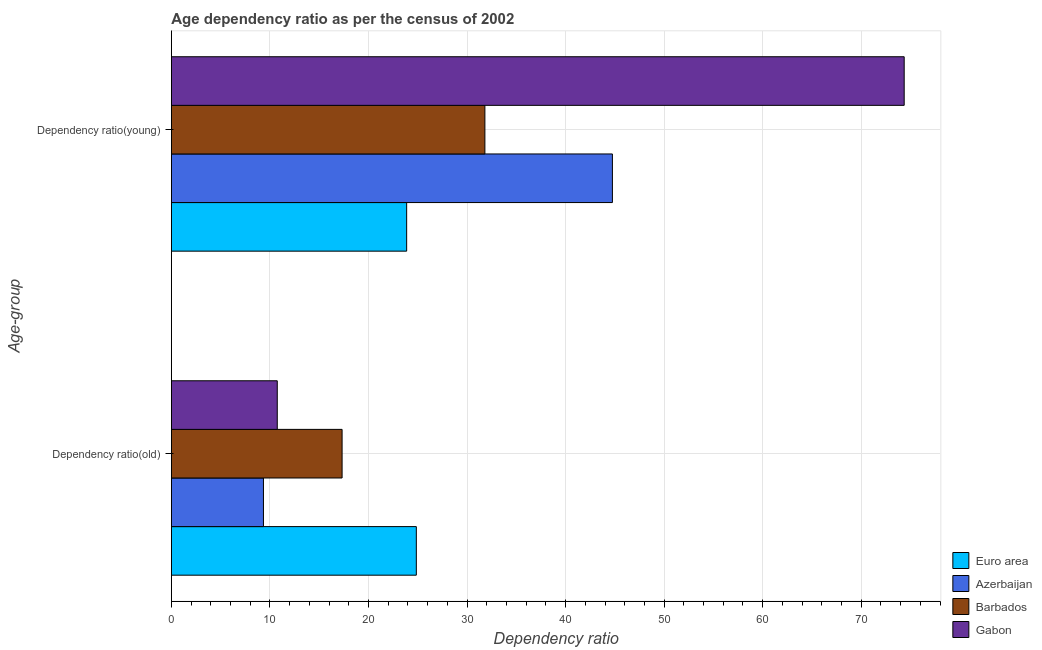How many groups of bars are there?
Offer a terse response. 2. How many bars are there on the 2nd tick from the bottom?
Your answer should be very brief. 4. What is the label of the 1st group of bars from the top?
Your answer should be compact. Dependency ratio(young). What is the age dependency ratio(old) in Barbados?
Your answer should be compact. 17.32. Across all countries, what is the maximum age dependency ratio(old)?
Keep it short and to the point. 24.85. Across all countries, what is the minimum age dependency ratio(young)?
Offer a terse response. 23.87. In which country was the age dependency ratio(old) minimum?
Make the answer very short. Azerbaijan. What is the total age dependency ratio(young) in the graph?
Your answer should be compact. 174.8. What is the difference between the age dependency ratio(young) in Azerbaijan and that in Barbados?
Make the answer very short. 12.94. What is the difference between the age dependency ratio(old) in Gabon and the age dependency ratio(young) in Barbados?
Give a very brief answer. -21.07. What is the average age dependency ratio(old) per country?
Offer a terse response. 15.57. What is the difference between the age dependency ratio(old) and age dependency ratio(young) in Azerbaijan?
Keep it short and to the point. -35.41. What is the ratio of the age dependency ratio(old) in Azerbaijan to that in Barbados?
Offer a terse response. 0.54. Is the age dependency ratio(old) in Gabon less than that in Euro area?
Keep it short and to the point. Yes. In how many countries, is the age dependency ratio(young) greater than the average age dependency ratio(young) taken over all countries?
Ensure brevity in your answer.  2. What does the 4th bar from the top in Dependency ratio(young) represents?
Make the answer very short. Euro area. What does the 2nd bar from the bottom in Dependency ratio(old) represents?
Your answer should be very brief. Azerbaijan. How many countries are there in the graph?
Your answer should be very brief. 4. Are the values on the major ticks of X-axis written in scientific E-notation?
Make the answer very short. No. Does the graph contain grids?
Your answer should be very brief. Yes. How many legend labels are there?
Offer a terse response. 4. How are the legend labels stacked?
Provide a short and direct response. Vertical. What is the title of the graph?
Make the answer very short. Age dependency ratio as per the census of 2002. What is the label or title of the X-axis?
Provide a short and direct response. Dependency ratio. What is the label or title of the Y-axis?
Your answer should be very brief. Age-group. What is the Dependency ratio in Euro area in Dependency ratio(old)?
Make the answer very short. 24.85. What is the Dependency ratio of Azerbaijan in Dependency ratio(old)?
Keep it short and to the point. 9.34. What is the Dependency ratio of Barbados in Dependency ratio(old)?
Give a very brief answer. 17.32. What is the Dependency ratio of Gabon in Dependency ratio(old)?
Make the answer very short. 10.74. What is the Dependency ratio of Euro area in Dependency ratio(young)?
Ensure brevity in your answer.  23.87. What is the Dependency ratio of Azerbaijan in Dependency ratio(young)?
Make the answer very short. 44.75. What is the Dependency ratio in Barbados in Dependency ratio(young)?
Offer a very short reply. 31.81. What is the Dependency ratio in Gabon in Dependency ratio(young)?
Keep it short and to the point. 74.36. Across all Age-group, what is the maximum Dependency ratio of Euro area?
Give a very brief answer. 24.85. Across all Age-group, what is the maximum Dependency ratio of Azerbaijan?
Your response must be concise. 44.75. Across all Age-group, what is the maximum Dependency ratio in Barbados?
Provide a succinct answer. 31.81. Across all Age-group, what is the maximum Dependency ratio of Gabon?
Offer a very short reply. 74.36. Across all Age-group, what is the minimum Dependency ratio in Euro area?
Offer a very short reply. 23.87. Across all Age-group, what is the minimum Dependency ratio in Azerbaijan?
Give a very brief answer. 9.34. Across all Age-group, what is the minimum Dependency ratio in Barbados?
Provide a succinct answer. 17.32. Across all Age-group, what is the minimum Dependency ratio of Gabon?
Provide a succinct answer. 10.74. What is the total Dependency ratio of Euro area in the graph?
Ensure brevity in your answer.  48.73. What is the total Dependency ratio in Azerbaijan in the graph?
Your answer should be very brief. 54.09. What is the total Dependency ratio of Barbados in the graph?
Offer a very short reply. 49.13. What is the total Dependency ratio in Gabon in the graph?
Ensure brevity in your answer.  85.1. What is the difference between the Dependency ratio of Azerbaijan in Dependency ratio(old) and that in Dependency ratio(young)?
Your answer should be compact. -35.41. What is the difference between the Dependency ratio in Barbados in Dependency ratio(old) and that in Dependency ratio(young)?
Your answer should be compact. -14.49. What is the difference between the Dependency ratio of Gabon in Dependency ratio(old) and that in Dependency ratio(young)?
Offer a very short reply. -63.62. What is the difference between the Dependency ratio of Euro area in Dependency ratio(old) and the Dependency ratio of Azerbaijan in Dependency ratio(young)?
Ensure brevity in your answer.  -19.9. What is the difference between the Dependency ratio of Euro area in Dependency ratio(old) and the Dependency ratio of Barbados in Dependency ratio(young)?
Ensure brevity in your answer.  -6.96. What is the difference between the Dependency ratio of Euro area in Dependency ratio(old) and the Dependency ratio of Gabon in Dependency ratio(young)?
Your answer should be very brief. -49.51. What is the difference between the Dependency ratio of Azerbaijan in Dependency ratio(old) and the Dependency ratio of Barbados in Dependency ratio(young)?
Ensure brevity in your answer.  -22.47. What is the difference between the Dependency ratio in Azerbaijan in Dependency ratio(old) and the Dependency ratio in Gabon in Dependency ratio(young)?
Offer a terse response. -65.02. What is the difference between the Dependency ratio of Barbados in Dependency ratio(old) and the Dependency ratio of Gabon in Dependency ratio(young)?
Keep it short and to the point. -57.04. What is the average Dependency ratio of Euro area per Age-group?
Ensure brevity in your answer.  24.36. What is the average Dependency ratio of Azerbaijan per Age-group?
Offer a terse response. 27.05. What is the average Dependency ratio of Barbados per Age-group?
Provide a succinct answer. 24.57. What is the average Dependency ratio of Gabon per Age-group?
Your answer should be very brief. 42.55. What is the difference between the Dependency ratio in Euro area and Dependency ratio in Azerbaijan in Dependency ratio(old)?
Offer a terse response. 15.51. What is the difference between the Dependency ratio in Euro area and Dependency ratio in Barbados in Dependency ratio(old)?
Your response must be concise. 7.53. What is the difference between the Dependency ratio of Euro area and Dependency ratio of Gabon in Dependency ratio(old)?
Keep it short and to the point. 14.11. What is the difference between the Dependency ratio in Azerbaijan and Dependency ratio in Barbados in Dependency ratio(old)?
Ensure brevity in your answer.  -7.98. What is the difference between the Dependency ratio in Azerbaijan and Dependency ratio in Gabon in Dependency ratio(old)?
Keep it short and to the point. -1.4. What is the difference between the Dependency ratio in Barbados and Dependency ratio in Gabon in Dependency ratio(old)?
Your answer should be compact. 6.58. What is the difference between the Dependency ratio of Euro area and Dependency ratio of Azerbaijan in Dependency ratio(young)?
Offer a very short reply. -20.88. What is the difference between the Dependency ratio of Euro area and Dependency ratio of Barbados in Dependency ratio(young)?
Give a very brief answer. -7.94. What is the difference between the Dependency ratio in Euro area and Dependency ratio in Gabon in Dependency ratio(young)?
Give a very brief answer. -50.49. What is the difference between the Dependency ratio of Azerbaijan and Dependency ratio of Barbados in Dependency ratio(young)?
Offer a terse response. 12.94. What is the difference between the Dependency ratio in Azerbaijan and Dependency ratio in Gabon in Dependency ratio(young)?
Keep it short and to the point. -29.61. What is the difference between the Dependency ratio in Barbados and Dependency ratio in Gabon in Dependency ratio(young)?
Ensure brevity in your answer.  -42.55. What is the ratio of the Dependency ratio of Euro area in Dependency ratio(old) to that in Dependency ratio(young)?
Make the answer very short. 1.04. What is the ratio of the Dependency ratio of Azerbaijan in Dependency ratio(old) to that in Dependency ratio(young)?
Give a very brief answer. 0.21. What is the ratio of the Dependency ratio in Barbados in Dependency ratio(old) to that in Dependency ratio(young)?
Ensure brevity in your answer.  0.54. What is the ratio of the Dependency ratio in Gabon in Dependency ratio(old) to that in Dependency ratio(young)?
Give a very brief answer. 0.14. What is the difference between the highest and the second highest Dependency ratio of Euro area?
Your response must be concise. 0.98. What is the difference between the highest and the second highest Dependency ratio in Azerbaijan?
Give a very brief answer. 35.41. What is the difference between the highest and the second highest Dependency ratio in Barbados?
Provide a succinct answer. 14.49. What is the difference between the highest and the second highest Dependency ratio of Gabon?
Your answer should be compact. 63.62. What is the difference between the highest and the lowest Dependency ratio in Azerbaijan?
Ensure brevity in your answer.  35.41. What is the difference between the highest and the lowest Dependency ratio in Barbados?
Give a very brief answer. 14.49. What is the difference between the highest and the lowest Dependency ratio of Gabon?
Keep it short and to the point. 63.62. 